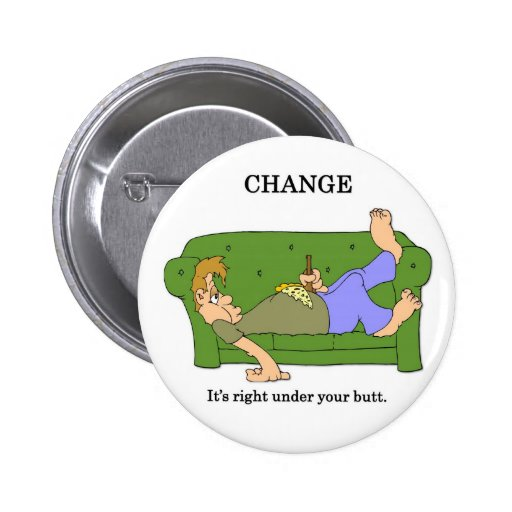Reflecting on the message of the image, how can someone take small steps towards positive change in their life? The message of the image underscores that significant changes often start from small, manageable actions. Someone looking to make positive changes in their life can start with simple steps such as setting achievable goals, maintaining a positive mindset, and gradually building healthy habits. Just like finding loose change under the couch, these small steps may seem insignificant at first but can collectively lead to substantial improvements over time. 